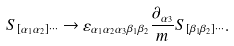<formula> <loc_0><loc_0><loc_500><loc_500>S _ { [ \alpha _ { 1 } \alpha _ { 2 } ] \cdots } \rightarrow \varepsilon _ { \alpha _ { 1 } \alpha _ { 2 } \alpha _ { 3 } \beta _ { 1 } \beta _ { 2 } } \frac { \partial _ { \alpha _ { 3 } } } { m } S _ { [ \beta _ { 1 } \beta _ { 2 } ] \cdots } .</formula> 